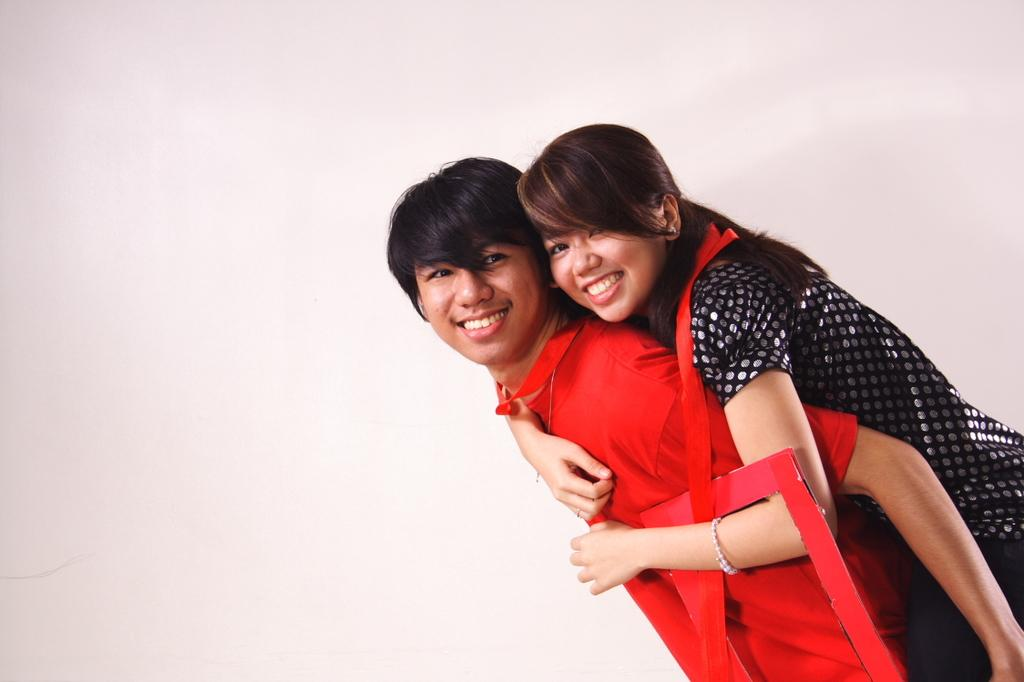Who is the main subject in the image? There is a man in the image. What is the man wearing? The man is wearing a red dress. What is the man doing in the image? The man is holding a woman. How does the woman appear in the image? The woman is smiling. What can be seen in the background of the image? There is a wall visible in the background of the image. What type of rose is the man holding in the image? There is no rose present in the image; the man is holding a woman. Is the man wearing a hat in the image? No, the man is not wearing a hat in the image; he is wearing a red dress. 